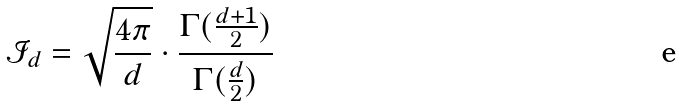<formula> <loc_0><loc_0><loc_500><loc_500>\mathcal { I } _ { d } = \sqrt { \frac { 4 \pi } { d } } \cdot \frac { \Gamma ( \frac { d + 1 } { 2 } ) } { \Gamma ( \frac { d } { 2 } ) }</formula> 